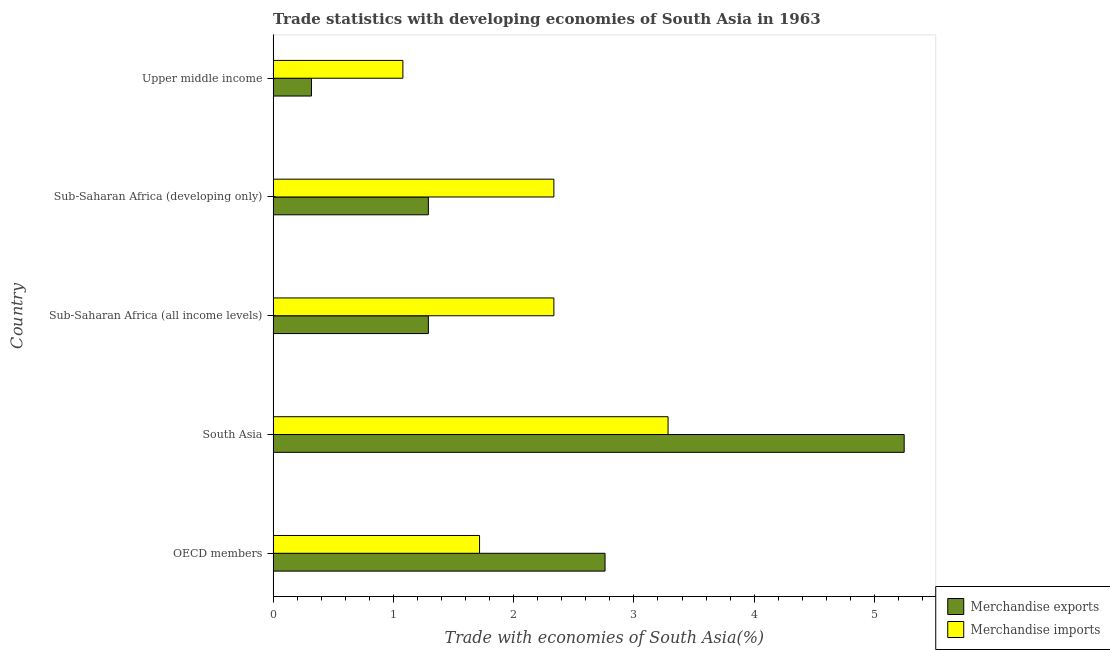How many groups of bars are there?
Make the answer very short. 5. Are the number of bars per tick equal to the number of legend labels?
Provide a short and direct response. Yes. Are the number of bars on each tick of the Y-axis equal?
Provide a short and direct response. Yes. What is the label of the 3rd group of bars from the top?
Give a very brief answer. Sub-Saharan Africa (all income levels). In how many cases, is the number of bars for a given country not equal to the number of legend labels?
Ensure brevity in your answer.  0. What is the merchandise imports in OECD members?
Make the answer very short. 1.72. Across all countries, what is the maximum merchandise imports?
Offer a very short reply. 3.28. Across all countries, what is the minimum merchandise exports?
Offer a very short reply. 0.32. In which country was the merchandise exports maximum?
Provide a succinct answer. South Asia. In which country was the merchandise exports minimum?
Provide a short and direct response. Upper middle income. What is the total merchandise exports in the graph?
Your response must be concise. 10.91. What is the difference between the merchandise imports in South Asia and the merchandise exports in Upper middle income?
Your answer should be compact. 2.97. What is the average merchandise exports per country?
Your answer should be very brief. 2.18. What is the difference between the merchandise imports and merchandise exports in Sub-Saharan Africa (all income levels)?
Offer a terse response. 1.04. In how many countries, is the merchandise imports greater than 3 %?
Your response must be concise. 1. What is the ratio of the merchandise exports in South Asia to that in Upper middle income?
Ensure brevity in your answer.  16.46. Is the difference between the merchandise imports in Sub-Saharan Africa (developing only) and Upper middle income greater than the difference between the merchandise exports in Sub-Saharan Africa (developing only) and Upper middle income?
Offer a terse response. Yes. What is the difference between the highest and the lowest merchandise imports?
Your answer should be very brief. 2.2. Is the sum of the merchandise imports in OECD members and South Asia greater than the maximum merchandise exports across all countries?
Provide a short and direct response. No. What does the 1st bar from the top in Sub-Saharan Africa (all income levels) represents?
Give a very brief answer. Merchandise imports. What does the 2nd bar from the bottom in Sub-Saharan Africa (developing only) represents?
Your answer should be compact. Merchandise imports. Are all the bars in the graph horizontal?
Offer a very short reply. Yes. How many countries are there in the graph?
Offer a terse response. 5. Are the values on the major ticks of X-axis written in scientific E-notation?
Your response must be concise. No. Does the graph contain grids?
Offer a very short reply. No. Where does the legend appear in the graph?
Offer a terse response. Bottom right. How many legend labels are there?
Keep it short and to the point. 2. How are the legend labels stacked?
Your answer should be compact. Vertical. What is the title of the graph?
Provide a short and direct response. Trade statistics with developing economies of South Asia in 1963. Does "Taxes on profits and capital gains" appear as one of the legend labels in the graph?
Give a very brief answer. No. What is the label or title of the X-axis?
Your answer should be very brief. Trade with economies of South Asia(%). What is the Trade with economies of South Asia(%) in Merchandise exports in OECD members?
Your response must be concise. 2.76. What is the Trade with economies of South Asia(%) in Merchandise imports in OECD members?
Offer a very short reply. 1.72. What is the Trade with economies of South Asia(%) of Merchandise exports in South Asia?
Keep it short and to the point. 5.25. What is the Trade with economies of South Asia(%) in Merchandise imports in South Asia?
Make the answer very short. 3.28. What is the Trade with economies of South Asia(%) of Merchandise exports in Sub-Saharan Africa (all income levels)?
Your answer should be very brief. 1.29. What is the Trade with economies of South Asia(%) of Merchandise imports in Sub-Saharan Africa (all income levels)?
Your response must be concise. 2.33. What is the Trade with economies of South Asia(%) in Merchandise exports in Sub-Saharan Africa (developing only)?
Offer a terse response. 1.29. What is the Trade with economies of South Asia(%) in Merchandise imports in Sub-Saharan Africa (developing only)?
Offer a terse response. 2.33. What is the Trade with economies of South Asia(%) of Merchandise exports in Upper middle income?
Make the answer very short. 0.32. What is the Trade with economies of South Asia(%) in Merchandise imports in Upper middle income?
Provide a succinct answer. 1.08. Across all countries, what is the maximum Trade with economies of South Asia(%) of Merchandise exports?
Your answer should be compact. 5.25. Across all countries, what is the maximum Trade with economies of South Asia(%) in Merchandise imports?
Provide a short and direct response. 3.28. Across all countries, what is the minimum Trade with economies of South Asia(%) in Merchandise exports?
Provide a succinct answer. 0.32. Across all countries, what is the minimum Trade with economies of South Asia(%) of Merchandise imports?
Make the answer very short. 1.08. What is the total Trade with economies of South Asia(%) in Merchandise exports in the graph?
Offer a terse response. 10.91. What is the total Trade with economies of South Asia(%) in Merchandise imports in the graph?
Your answer should be compact. 10.75. What is the difference between the Trade with economies of South Asia(%) in Merchandise exports in OECD members and that in South Asia?
Give a very brief answer. -2.49. What is the difference between the Trade with economies of South Asia(%) in Merchandise imports in OECD members and that in South Asia?
Provide a short and direct response. -1.57. What is the difference between the Trade with economies of South Asia(%) in Merchandise exports in OECD members and that in Sub-Saharan Africa (all income levels)?
Provide a short and direct response. 1.47. What is the difference between the Trade with economies of South Asia(%) of Merchandise imports in OECD members and that in Sub-Saharan Africa (all income levels)?
Your answer should be very brief. -0.62. What is the difference between the Trade with economies of South Asia(%) of Merchandise exports in OECD members and that in Sub-Saharan Africa (developing only)?
Offer a terse response. 1.47. What is the difference between the Trade with economies of South Asia(%) of Merchandise imports in OECD members and that in Sub-Saharan Africa (developing only)?
Offer a very short reply. -0.62. What is the difference between the Trade with economies of South Asia(%) in Merchandise exports in OECD members and that in Upper middle income?
Provide a short and direct response. 2.44. What is the difference between the Trade with economies of South Asia(%) of Merchandise imports in OECD members and that in Upper middle income?
Offer a terse response. 0.64. What is the difference between the Trade with economies of South Asia(%) of Merchandise exports in South Asia and that in Sub-Saharan Africa (all income levels)?
Make the answer very short. 3.96. What is the difference between the Trade with economies of South Asia(%) of Merchandise imports in South Asia and that in Sub-Saharan Africa (all income levels)?
Offer a very short reply. 0.95. What is the difference between the Trade with economies of South Asia(%) in Merchandise exports in South Asia and that in Sub-Saharan Africa (developing only)?
Ensure brevity in your answer.  3.96. What is the difference between the Trade with economies of South Asia(%) in Merchandise imports in South Asia and that in Sub-Saharan Africa (developing only)?
Provide a short and direct response. 0.95. What is the difference between the Trade with economies of South Asia(%) of Merchandise exports in South Asia and that in Upper middle income?
Your answer should be compact. 4.93. What is the difference between the Trade with economies of South Asia(%) of Merchandise imports in South Asia and that in Upper middle income?
Provide a short and direct response. 2.2. What is the difference between the Trade with economies of South Asia(%) of Merchandise imports in Sub-Saharan Africa (all income levels) and that in Sub-Saharan Africa (developing only)?
Offer a terse response. 0. What is the difference between the Trade with economies of South Asia(%) in Merchandise exports in Sub-Saharan Africa (all income levels) and that in Upper middle income?
Keep it short and to the point. 0.97. What is the difference between the Trade with economies of South Asia(%) in Merchandise imports in Sub-Saharan Africa (all income levels) and that in Upper middle income?
Provide a succinct answer. 1.26. What is the difference between the Trade with economies of South Asia(%) of Merchandise exports in Sub-Saharan Africa (developing only) and that in Upper middle income?
Keep it short and to the point. 0.97. What is the difference between the Trade with economies of South Asia(%) of Merchandise imports in Sub-Saharan Africa (developing only) and that in Upper middle income?
Give a very brief answer. 1.26. What is the difference between the Trade with economies of South Asia(%) in Merchandise exports in OECD members and the Trade with economies of South Asia(%) in Merchandise imports in South Asia?
Ensure brevity in your answer.  -0.52. What is the difference between the Trade with economies of South Asia(%) of Merchandise exports in OECD members and the Trade with economies of South Asia(%) of Merchandise imports in Sub-Saharan Africa (all income levels)?
Provide a short and direct response. 0.43. What is the difference between the Trade with economies of South Asia(%) in Merchandise exports in OECD members and the Trade with economies of South Asia(%) in Merchandise imports in Sub-Saharan Africa (developing only)?
Offer a very short reply. 0.43. What is the difference between the Trade with economies of South Asia(%) of Merchandise exports in OECD members and the Trade with economies of South Asia(%) of Merchandise imports in Upper middle income?
Give a very brief answer. 1.68. What is the difference between the Trade with economies of South Asia(%) of Merchandise exports in South Asia and the Trade with economies of South Asia(%) of Merchandise imports in Sub-Saharan Africa (all income levels)?
Give a very brief answer. 2.91. What is the difference between the Trade with economies of South Asia(%) of Merchandise exports in South Asia and the Trade with economies of South Asia(%) of Merchandise imports in Sub-Saharan Africa (developing only)?
Keep it short and to the point. 2.91. What is the difference between the Trade with economies of South Asia(%) in Merchandise exports in South Asia and the Trade with economies of South Asia(%) in Merchandise imports in Upper middle income?
Offer a very short reply. 4.17. What is the difference between the Trade with economies of South Asia(%) in Merchandise exports in Sub-Saharan Africa (all income levels) and the Trade with economies of South Asia(%) in Merchandise imports in Sub-Saharan Africa (developing only)?
Keep it short and to the point. -1.04. What is the difference between the Trade with economies of South Asia(%) in Merchandise exports in Sub-Saharan Africa (all income levels) and the Trade with economies of South Asia(%) in Merchandise imports in Upper middle income?
Your answer should be very brief. 0.21. What is the difference between the Trade with economies of South Asia(%) of Merchandise exports in Sub-Saharan Africa (developing only) and the Trade with economies of South Asia(%) of Merchandise imports in Upper middle income?
Offer a terse response. 0.21. What is the average Trade with economies of South Asia(%) in Merchandise exports per country?
Provide a short and direct response. 2.18. What is the average Trade with economies of South Asia(%) in Merchandise imports per country?
Offer a terse response. 2.15. What is the difference between the Trade with economies of South Asia(%) of Merchandise exports and Trade with economies of South Asia(%) of Merchandise imports in OECD members?
Your response must be concise. 1.04. What is the difference between the Trade with economies of South Asia(%) in Merchandise exports and Trade with economies of South Asia(%) in Merchandise imports in South Asia?
Offer a terse response. 1.96. What is the difference between the Trade with economies of South Asia(%) in Merchandise exports and Trade with economies of South Asia(%) in Merchandise imports in Sub-Saharan Africa (all income levels)?
Provide a short and direct response. -1.04. What is the difference between the Trade with economies of South Asia(%) in Merchandise exports and Trade with economies of South Asia(%) in Merchandise imports in Sub-Saharan Africa (developing only)?
Make the answer very short. -1.04. What is the difference between the Trade with economies of South Asia(%) of Merchandise exports and Trade with economies of South Asia(%) of Merchandise imports in Upper middle income?
Give a very brief answer. -0.76. What is the ratio of the Trade with economies of South Asia(%) of Merchandise exports in OECD members to that in South Asia?
Your response must be concise. 0.53. What is the ratio of the Trade with economies of South Asia(%) of Merchandise imports in OECD members to that in South Asia?
Give a very brief answer. 0.52. What is the ratio of the Trade with economies of South Asia(%) of Merchandise exports in OECD members to that in Sub-Saharan Africa (all income levels)?
Offer a very short reply. 2.14. What is the ratio of the Trade with economies of South Asia(%) in Merchandise imports in OECD members to that in Sub-Saharan Africa (all income levels)?
Give a very brief answer. 0.74. What is the ratio of the Trade with economies of South Asia(%) of Merchandise exports in OECD members to that in Sub-Saharan Africa (developing only)?
Your response must be concise. 2.14. What is the ratio of the Trade with economies of South Asia(%) in Merchandise imports in OECD members to that in Sub-Saharan Africa (developing only)?
Ensure brevity in your answer.  0.74. What is the ratio of the Trade with economies of South Asia(%) of Merchandise exports in OECD members to that in Upper middle income?
Ensure brevity in your answer.  8.66. What is the ratio of the Trade with economies of South Asia(%) in Merchandise imports in OECD members to that in Upper middle income?
Keep it short and to the point. 1.59. What is the ratio of the Trade with economies of South Asia(%) in Merchandise exports in South Asia to that in Sub-Saharan Africa (all income levels)?
Your response must be concise. 4.06. What is the ratio of the Trade with economies of South Asia(%) of Merchandise imports in South Asia to that in Sub-Saharan Africa (all income levels)?
Offer a very short reply. 1.41. What is the ratio of the Trade with economies of South Asia(%) of Merchandise exports in South Asia to that in Sub-Saharan Africa (developing only)?
Your response must be concise. 4.06. What is the ratio of the Trade with economies of South Asia(%) in Merchandise imports in South Asia to that in Sub-Saharan Africa (developing only)?
Offer a very short reply. 1.41. What is the ratio of the Trade with economies of South Asia(%) of Merchandise exports in South Asia to that in Upper middle income?
Give a very brief answer. 16.46. What is the ratio of the Trade with economies of South Asia(%) of Merchandise imports in South Asia to that in Upper middle income?
Ensure brevity in your answer.  3.04. What is the ratio of the Trade with economies of South Asia(%) in Merchandise exports in Sub-Saharan Africa (all income levels) to that in Sub-Saharan Africa (developing only)?
Your answer should be very brief. 1. What is the ratio of the Trade with economies of South Asia(%) of Merchandise exports in Sub-Saharan Africa (all income levels) to that in Upper middle income?
Ensure brevity in your answer.  4.05. What is the ratio of the Trade with economies of South Asia(%) of Merchandise imports in Sub-Saharan Africa (all income levels) to that in Upper middle income?
Provide a succinct answer. 2.16. What is the ratio of the Trade with economies of South Asia(%) of Merchandise exports in Sub-Saharan Africa (developing only) to that in Upper middle income?
Your answer should be very brief. 4.05. What is the ratio of the Trade with economies of South Asia(%) in Merchandise imports in Sub-Saharan Africa (developing only) to that in Upper middle income?
Your response must be concise. 2.16. What is the difference between the highest and the second highest Trade with economies of South Asia(%) in Merchandise exports?
Your answer should be compact. 2.49. What is the difference between the highest and the second highest Trade with economies of South Asia(%) in Merchandise imports?
Provide a succinct answer. 0.95. What is the difference between the highest and the lowest Trade with economies of South Asia(%) of Merchandise exports?
Offer a very short reply. 4.93. What is the difference between the highest and the lowest Trade with economies of South Asia(%) of Merchandise imports?
Keep it short and to the point. 2.2. 